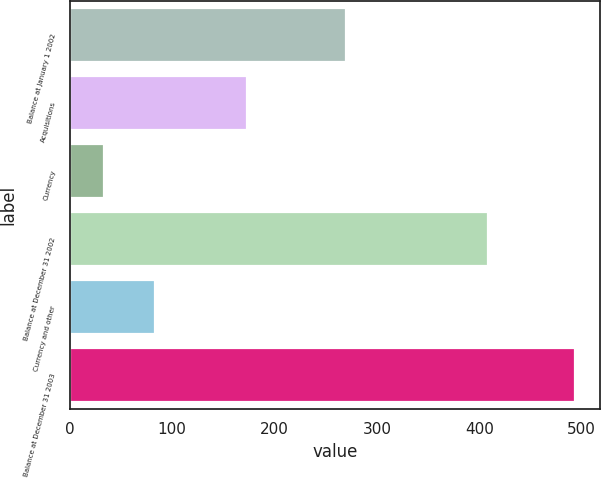<chart> <loc_0><loc_0><loc_500><loc_500><bar_chart><fcel>Balance at January 1 2002<fcel>Acquisitions<fcel>Currency<fcel>Balance at December 31 2002<fcel>Currency and other<fcel>Balance at December 31 2003<nl><fcel>269.3<fcel>173<fcel>33.8<fcel>408.5<fcel>83.3<fcel>493.6<nl></chart> 